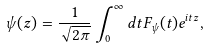Convert formula to latex. <formula><loc_0><loc_0><loc_500><loc_500>\psi ( z ) = \frac { 1 } { \sqrt { 2 \pi } } \int _ { 0 } ^ { \infty } d t F _ { \psi } ( t ) e ^ { i t z } ,</formula> 